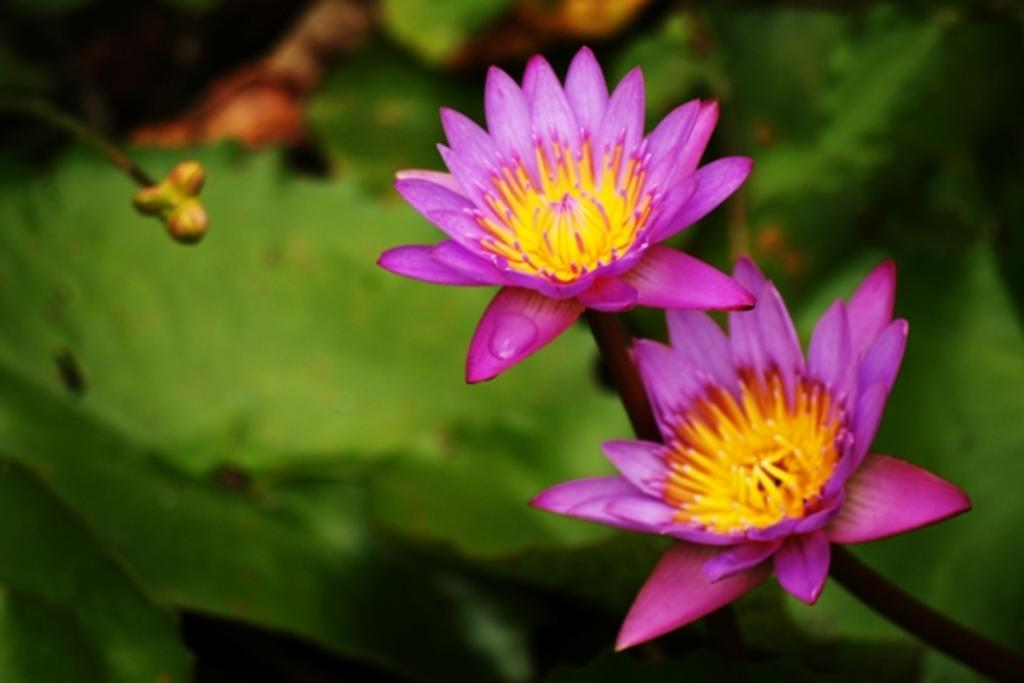What is located in the front of the image? There are flowers in the front of the image. Can you describe the background of the image? The background of the image is blurry. What type of shock can be seen in the image? There is no shock present in the image; it features flowers in the front and a blurry background. 